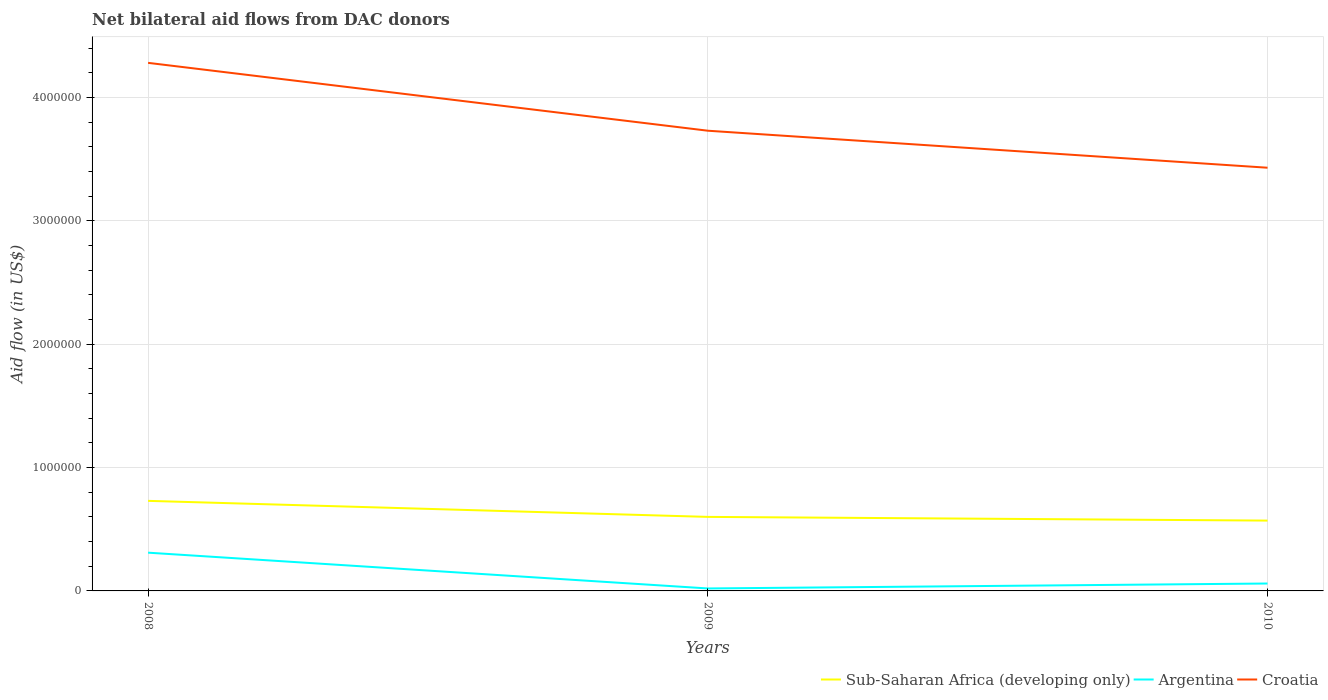Does the line corresponding to Sub-Saharan Africa (developing only) intersect with the line corresponding to Croatia?
Keep it short and to the point. No. Is the number of lines equal to the number of legend labels?
Your response must be concise. Yes. What is the total net bilateral aid flow in Croatia in the graph?
Ensure brevity in your answer.  5.50e+05. What is the difference between the highest and the second highest net bilateral aid flow in Sub-Saharan Africa (developing only)?
Offer a terse response. 1.60e+05. How many lines are there?
Give a very brief answer. 3. How many years are there in the graph?
Offer a very short reply. 3. What is the difference between two consecutive major ticks on the Y-axis?
Keep it short and to the point. 1.00e+06. Does the graph contain any zero values?
Provide a succinct answer. No. Where does the legend appear in the graph?
Offer a terse response. Bottom right. What is the title of the graph?
Make the answer very short. Net bilateral aid flows from DAC donors. What is the label or title of the X-axis?
Ensure brevity in your answer.  Years. What is the label or title of the Y-axis?
Ensure brevity in your answer.  Aid flow (in US$). What is the Aid flow (in US$) of Sub-Saharan Africa (developing only) in 2008?
Your response must be concise. 7.30e+05. What is the Aid flow (in US$) in Croatia in 2008?
Your answer should be compact. 4.28e+06. What is the Aid flow (in US$) in Argentina in 2009?
Make the answer very short. 2.00e+04. What is the Aid flow (in US$) of Croatia in 2009?
Your response must be concise. 3.73e+06. What is the Aid flow (in US$) of Sub-Saharan Africa (developing only) in 2010?
Provide a succinct answer. 5.70e+05. What is the Aid flow (in US$) of Croatia in 2010?
Ensure brevity in your answer.  3.43e+06. Across all years, what is the maximum Aid flow (in US$) of Sub-Saharan Africa (developing only)?
Give a very brief answer. 7.30e+05. Across all years, what is the maximum Aid flow (in US$) in Croatia?
Provide a succinct answer. 4.28e+06. Across all years, what is the minimum Aid flow (in US$) of Sub-Saharan Africa (developing only)?
Ensure brevity in your answer.  5.70e+05. Across all years, what is the minimum Aid flow (in US$) of Croatia?
Your answer should be very brief. 3.43e+06. What is the total Aid flow (in US$) in Sub-Saharan Africa (developing only) in the graph?
Provide a succinct answer. 1.90e+06. What is the total Aid flow (in US$) in Croatia in the graph?
Provide a short and direct response. 1.14e+07. What is the difference between the Aid flow (in US$) of Argentina in 2008 and that in 2009?
Your response must be concise. 2.90e+05. What is the difference between the Aid flow (in US$) in Argentina in 2008 and that in 2010?
Provide a succinct answer. 2.50e+05. What is the difference between the Aid flow (in US$) of Croatia in 2008 and that in 2010?
Ensure brevity in your answer.  8.50e+05. What is the difference between the Aid flow (in US$) in Sub-Saharan Africa (developing only) in 2009 and that in 2010?
Offer a terse response. 3.00e+04. What is the difference between the Aid flow (in US$) of Croatia in 2009 and that in 2010?
Make the answer very short. 3.00e+05. What is the difference between the Aid flow (in US$) in Sub-Saharan Africa (developing only) in 2008 and the Aid flow (in US$) in Argentina in 2009?
Provide a short and direct response. 7.10e+05. What is the difference between the Aid flow (in US$) in Sub-Saharan Africa (developing only) in 2008 and the Aid flow (in US$) in Croatia in 2009?
Your response must be concise. -3.00e+06. What is the difference between the Aid flow (in US$) in Argentina in 2008 and the Aid flow (in US$) in Croatia in 2009?
Make the answer very short. -3.42e+06. What is the difference between the Aid flow (in US$) of Sub-Saharan Africa (developing only) in 2008 and the Aid flow (in US$) of Argentina in 2010?
Provide a succinct answer. 6.70e+05. What is the difference between the Aid flow (in US$) in Sub-Saharan Africa (developing only) in 2008 and the Aid flow (in US$) in Croatia in 2010?
Give a very brief answer. -2.70e+06. What is the difference between the Aid flow (in US$) of Argentina in 2008 and the Aid flow (in US$) of Croatia in 2010?
Your response must be concise. -3.12e+06. What is the difference between the Aid flow (in US$) in Sub-Saharan Africa (developing only) in 2009 and the Aid flow (in US$) in Argentina in 2010?
Offer a terse response. 5.40e+05. What is the difference between the Aid flow (in US$) in Sub-Saharan Africa (developing only) in 2009 and the Aid flow (in US$) in Croatia in 2010?
Your answer should be very brief. -2.83e+06. What is the difference between the Aid flow (in US$) of Argentina in 2009 and the Aid flow (in US$) of Croatia in 2010?
Your response must be concise. -3.41e+06. What is the average Aid flow (in US$) of Sub-Saharan Africa (developing only) per year?
Ensure brevity in your answer.  6.33e+05. What is the average Aid flow (in US$) in Argentina per year?
Your answer should be compact. 1.30e+05. What is the average Aid flow (in US$) in Croatia per year?
Give a very brief answer. 3.81e+06. In the year 2008, what is the difference between the Aid flow (in US$) of Sub-Saharan Africa (developing only) and Aid flow (in US$) of Croatia?
Make the answer very short. -3.55e+06. In the year 2008, what is the difference between the Aid flow (in US$) in Argentina and Aid flow (in US$) in Croatia?
Provide a short and direct response. -3.97e+06. In the year 2009, what is the difference between the Aid flow (in US$) of Sub-Saharan Africa (developing only) and Aid flow (in US$) of Argentina?
Your answer should be very brief. 5.80e+05. In the year 2009, what is the difference between the Aid flow (in US$) in Sub-Saharan Africa (developing only) and Aid flow (in US$) in Croatia?
Keep it short and to the point. -3.13e+06. In the year 2009, what is the difference between the Aid flow (in US$) of Argentina and Aid flow (in US$) of Croatia?
Give a very brief answer. -3.71e+06. In the year 2010, what is the difference between the Aid flow (in US$) in Sub-Saharan Africa (developing only) and Aid flow (in US$) in Argentina?
Provide a succinct answer. 5.10e+05. In the year 2010, what is the difference between the Aid flow (in US$) of Sub-Saharan Africa (developing only) and Aid flow (in US$) of Croatia?
Give a very brief answer. -2.86e+06. In the year 2010, what is the difference between the Aid flow (in US$) of Argentina and Aid flow (in US$) of Croatia?
Offer a very short reply. -3.37e+06. What is the ratio of the Aid flow (in US$) of Sub-Saharan Africa (developing only) in 2008 to that in 2009?
Provide a short and direct response. 1.22. What is the ratio of the Aid flow (in US$) in Argentina in 2008 to that in 2009?
Offer a terse response. 15.5. What is the ratio of the Aid flow (in US$) in Croatia in 2008 to that in 2009?
Provide a short and direct response. 1.15. What is the ratio of the Aid flow (in US$) in Sub-Saharan Africa (developing only) in 2008 to that in 2010?
Your answer should be compact. 1.28. What is the ratio of the Aid flow (in US$) of Argentina in 2008 to that in 2010?
Your answer should be compact. 5.17. What is the ratio of the Aid flow (in US$) in Croatia in 2008 to that in 2010?
Your answer should be compact. 1.25. What is the ratio of the Aid flow (in US$) in Sub-Saharan Africa (developing only) in 2009 to that in 2010?
Give a very brief answer. 1.05. What is the ratio of the Aid flow (in US$) in Croatia in 2009 to that in 2010?
Make the answer very short. 1.09. What is the difference between the highest and the second highest Aid flow (in US$) of Sub-Saharan Africa (developing only)?
Provide a succinct answer. 1.30e+05. What is the difference between the highest and the second highest Aid flow (in US$) in Argentina?
Give a very brief answer. 2.50e+05. What is the difference between the highest and the lowest Aid flow (in US$) in Argentina?
Provide a succinct answer. 2.90e+05. What is the difference between the highest and the lowest Aid flow (in US$) in Croatia?
Your response must be concise. 8.50e+05. 